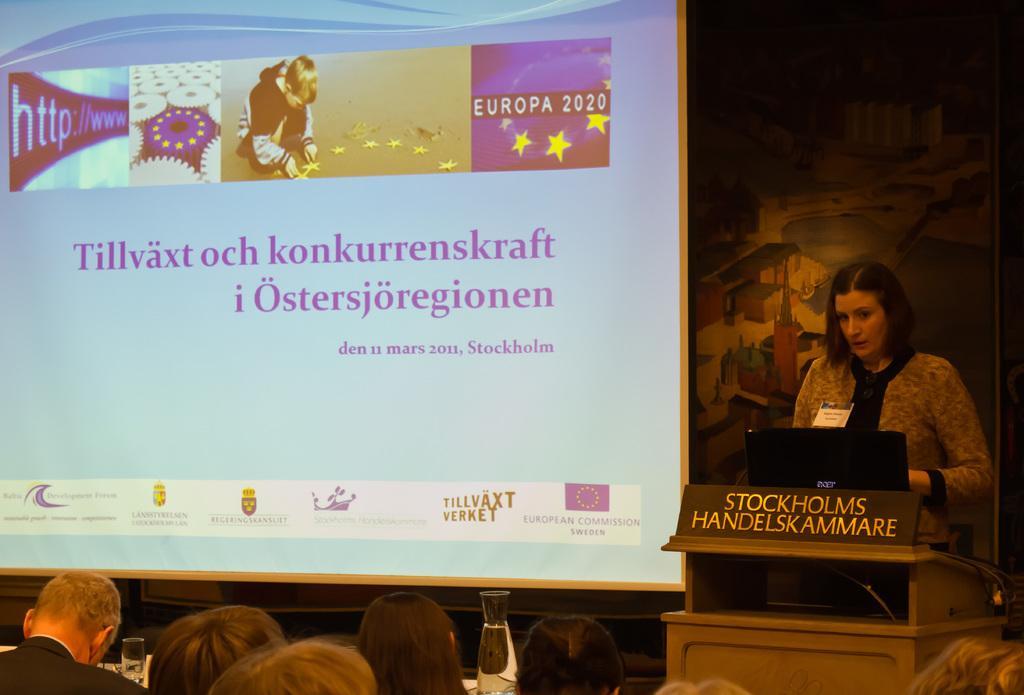How would you summarize this image in a sentence or two? In this picture I can see there is a woman standing and speaking, she is having a wooden table in front of her and there is a laptop in front her and there are few people sitting here and there is a screen in the backdrop. 